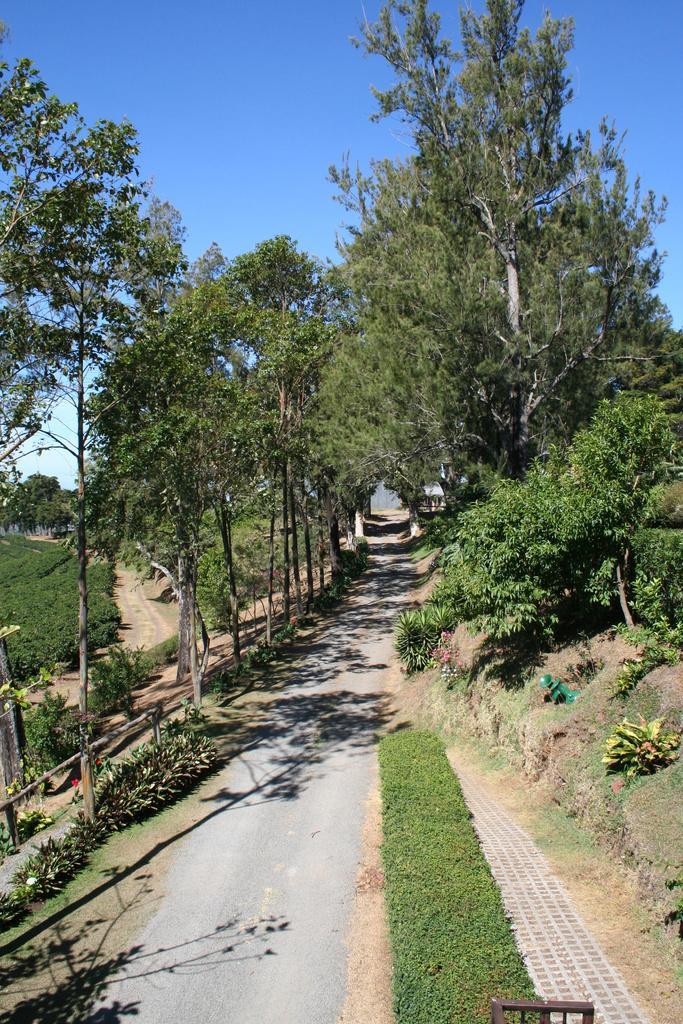Describe this image in one or two sentences. In the image we can see there are trees and the ground is covered with grass. There is a clear sky. 